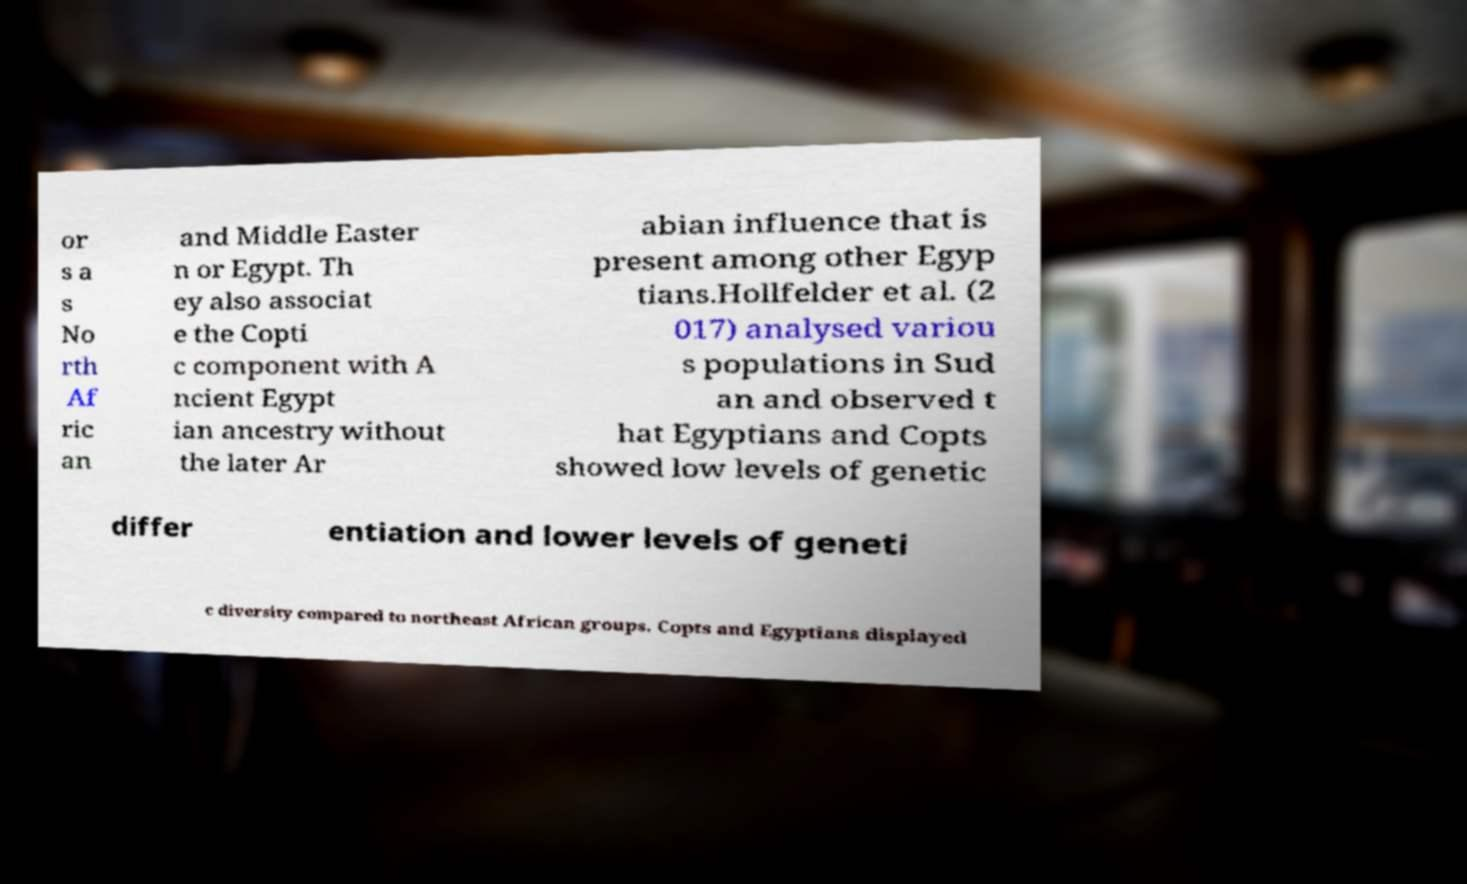For documentation purposes, I need the text within this image transcribed. Could you provide that? or s a s No rth Af ric an and Middle Easter n or Egypt. Th ey also associat e the Copti c component with A ncient Egypt ian ancestry without the later Ar abian influence that is present among other Egyp tians.Hollfelder et al. (2 017) analysed variou s populations in Sud an and observed t hat Egyptians and Copts showed low levels of genetic differ entiation and lower levels of geneti c diversity compared to northeast African groups. Copts and Egyptians displayed 